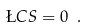<formula> <loc_0><loc_0><loc_500><loc_500>\L C S = 0 \ .</formula> 